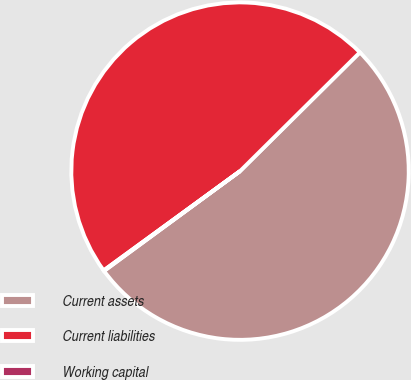<chart> <loc_0><loc_0><loc_500><loc_500><pie_chart><fcel>Current assets<fcel>Current liabilities<fcel>Working capital<nl><fcel>52.35%<fcel>47.59%<fcel>0.06%<nl></chart> 